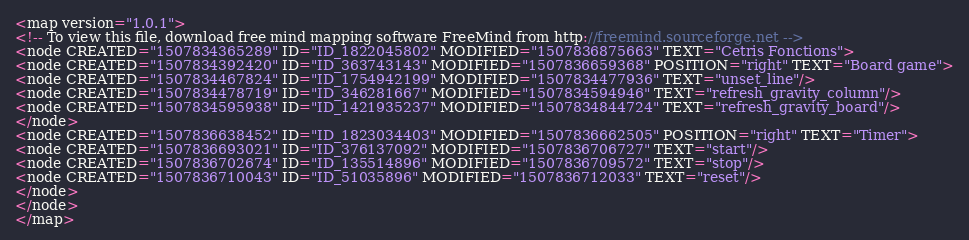Convert code to text. <code><loc_0><loc_0><loc_500><loc_500><_ObjectiveC_><map version="1.0.1">
<!-- To view this file, download free mind mapping software FreeMind from http://freemind.sourceforge.net -->
<node CREATED="1507834365289" ID="ID_1822045802" MODIFIED="1507836875663" TEXT="Cetris Fonctions">
<node CREATED="1507834392420" ID="ID_363743143" MODIFIED="1507836659368" POSITION="right" TEXT="Board game">
<node CREATED="1507834467824" ID="ID_1754942199" MODIFIED="1507834477936" TEXT="unset_line"/>
<node CREATED="1507834478719" ID="ID_346281667" MODIFIED="1507834594946" TEXT="refresh_gravity_column"/>
<node CREATED="1507834595938" ID="ID_1421935237" MODIFIED="1507834844724" TEXT="refresh_gravity_board"/>
</node>
<node CREATED="1507836638452" ID="ID_1823034403" MODIFIED="1507836662505" POSITION="right" TEXT="Timer">
<node CREATED="1507836693021" ID="ID_376137092" MODIFIED="1507836706727" TEXT="start"/>
<node CREATED="1507836702674" ID="ID_135514896" MODIFIED="1507836709572" TEXT="stop"/>
<node CREATED="1507836710043" ID="ID_51035896" MODIFIED="1507836712033" TEXT="reset"/>
</node>
</node>
</map>
</code> 